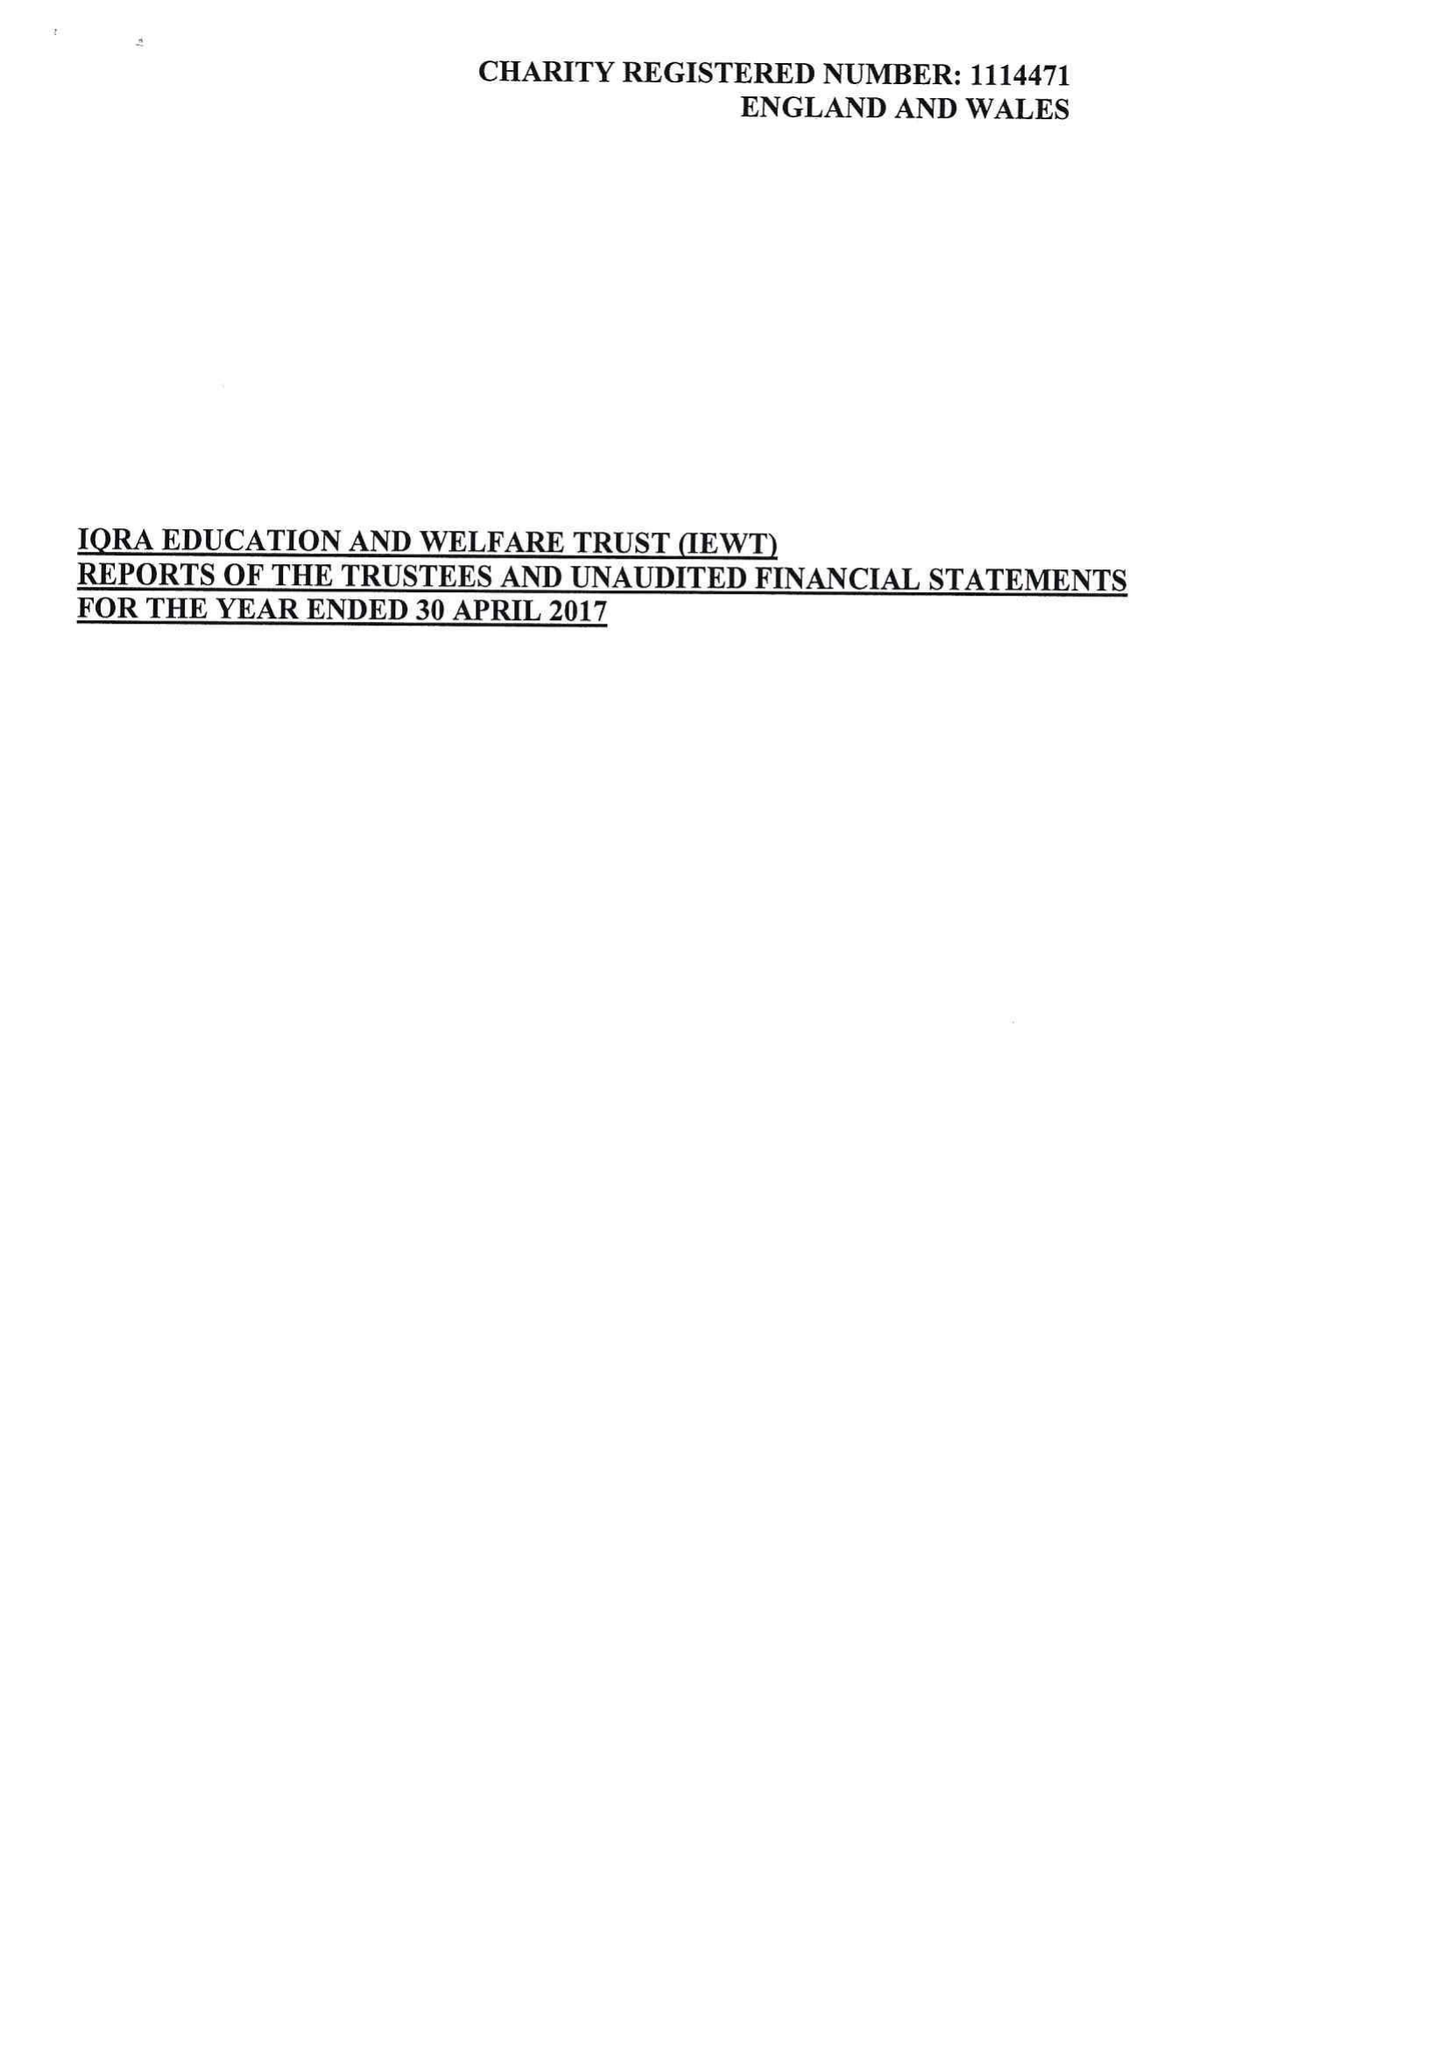What is the value for the address__street_line?
Answer the question using a single word or phrase. 319 WATERLOO STREET 